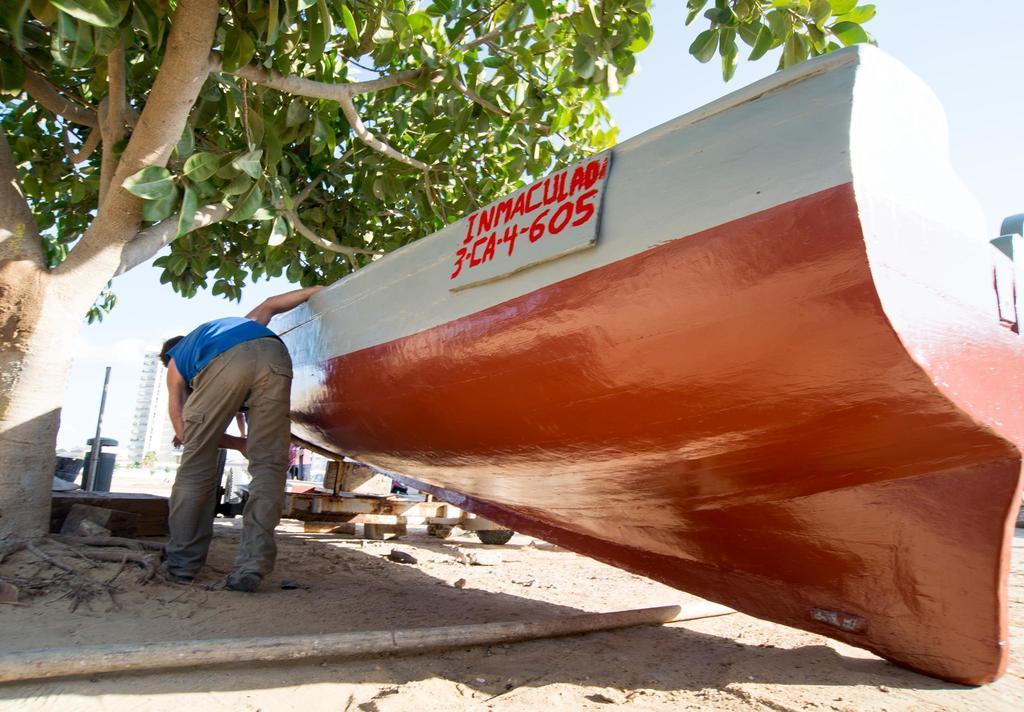Please provide a concise description of this image. In this picture we can see an object, name board, person, tree, wooden stick on the ground and in the background we can see some objects and the sky. 